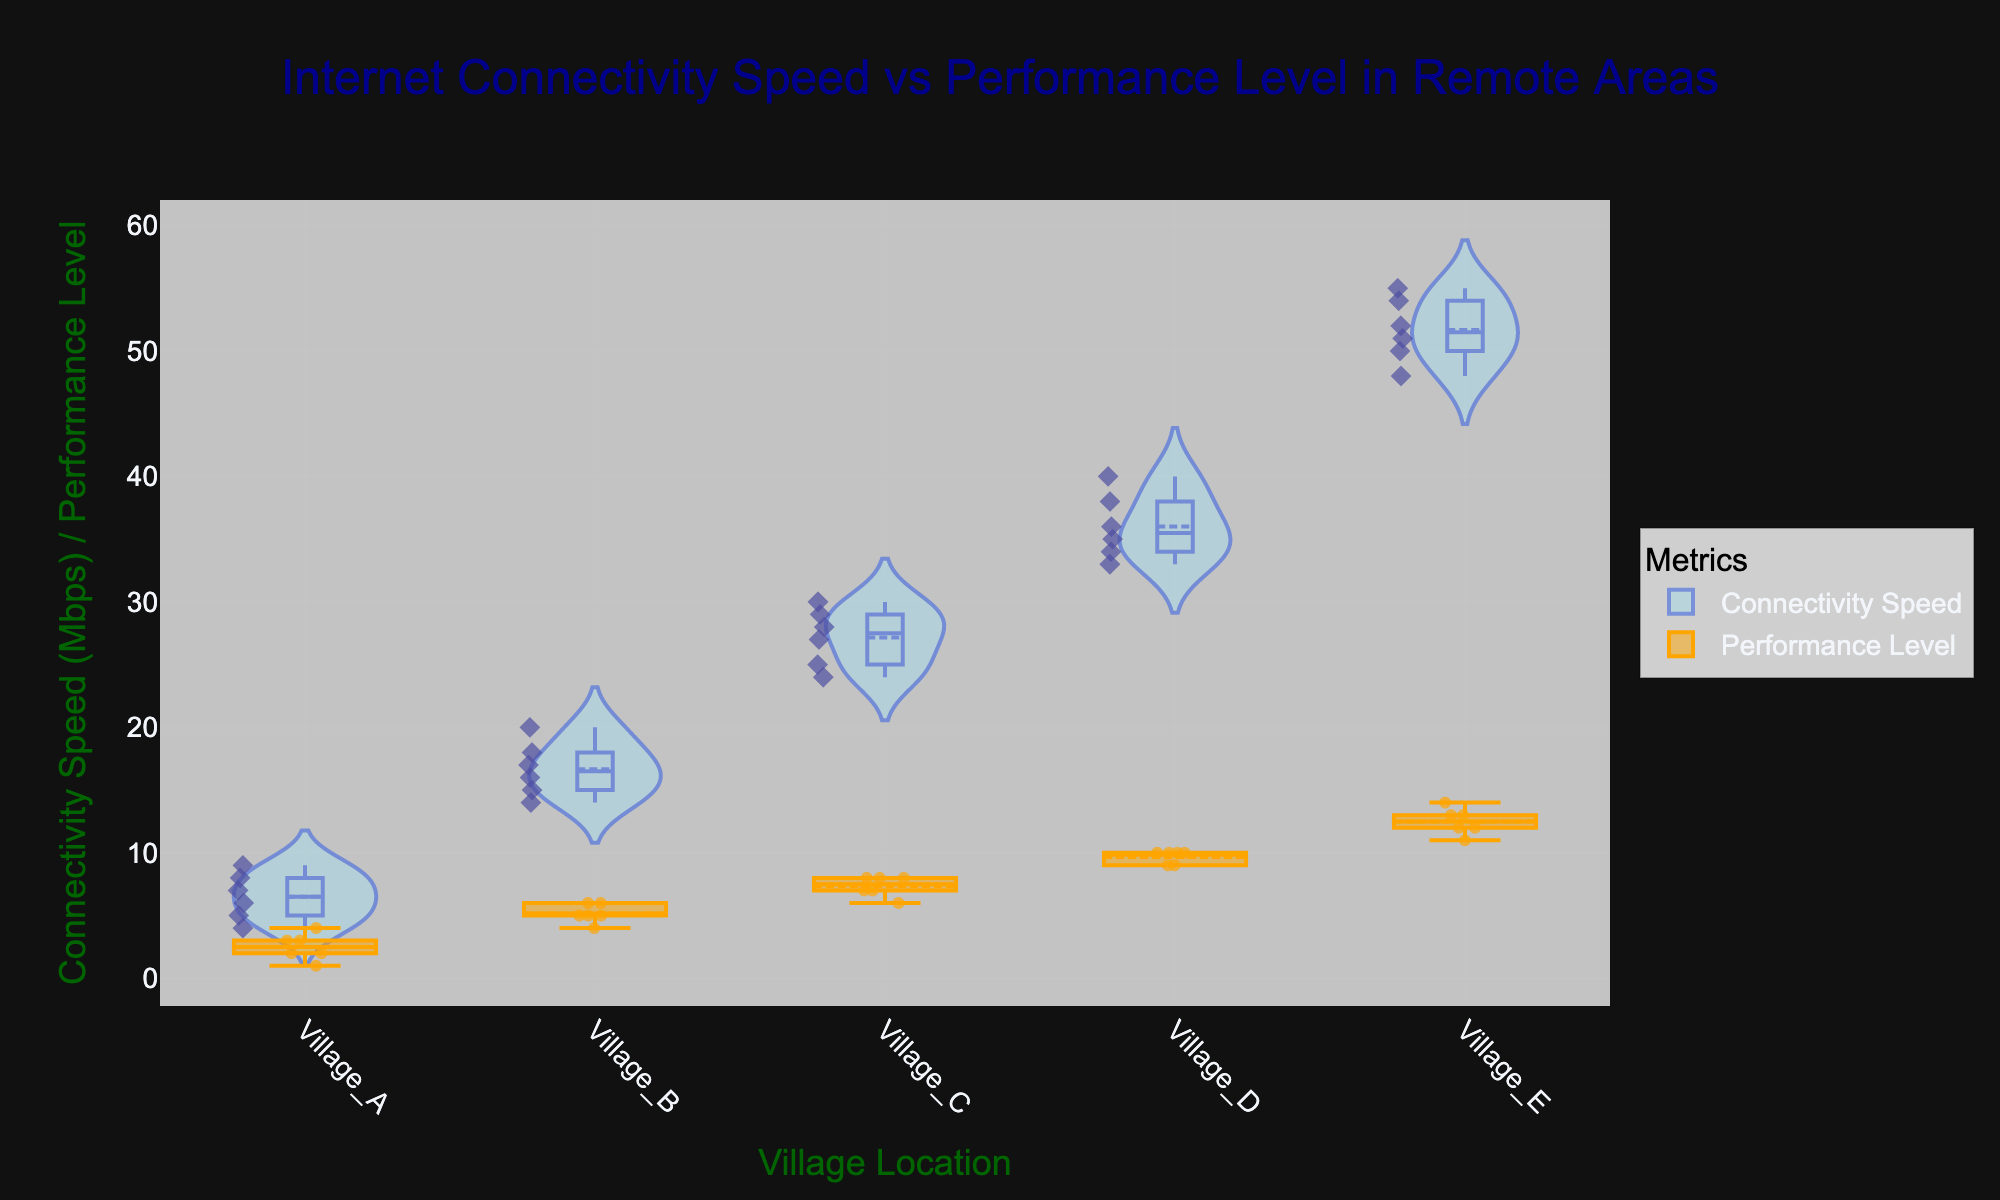What is the title of the figure? The title of the figure is shown at the top of the plot. Reading it reveals that it is 'Internet Connectivity Speed vs Performance Level in Remote Areas'.
Answer: Internet Connectivity Speed vs Performance Level in Remote Areas Which village has the highest median connectivity speed? The violin plot reveals the median value with a central line. Village E has the highest median line, indicating the highest median connectivity speed.
Answer: Village E What are the x-axis and y-axis titles? The axis titles provide information about what each axis represents. The x-axis is labeled 'Village Location', and the y-axis is labeled 'Connectivity Speed (Mbps) / Performance Level'.
Answer: Village Location (x-axis), Connectivity Speed (Mbps) / Performance Level (y-axis) How many data points are displayed for Village B? Each data point for a violin or box plot is represented by a marker. Counting the markers for Village B on both plots indicates there are 6 data points.
Answer: 6 Based on the box plot, which village has the most consistent performance levels? Consistency in performance levels can be identified by looking at the spread of the box plot. The smaller the spread, the more consistent the performance levels. Village D has the smallest spread in its box plot, indicating the most consistent performance levels.
Answer: Village D Compare the connectivity speeds between Village A and Village C. Which one has higher speeds? To determine this, observe the range and central tendencies (median) of the violin plots. Village C shows a higher median and higher range of connectivity speeds compared to Village A.
Answer: Village C What is the color of the markers used to represent data points in the violin plot? The color of the markers in the violin plot can be identified by observation. They are colored dark blue.
Answer: Dark blue Which village has the lowest maximum connectivity speed? The maximum value is indicated by the top end of the violin plot. Village A has the lowest top end, indicating it has the lowest maximum connectivity speed.
Answer: Village A Compare the median performance levels of Village C and Village D. Which one has a higher median? The median performance level is shown by the central line within each box plot. Comparing these lines reveals that Village D has a higher median performance level than Village C.
Answer: Village D How does the variability of connectivity speeds differ between Village E and Village A? Variability can be assessed by the spread or width of the violin plots. Village E has a wider spread than Village A, indicating higher variability in connectivity speeds.
Answer: Village E 